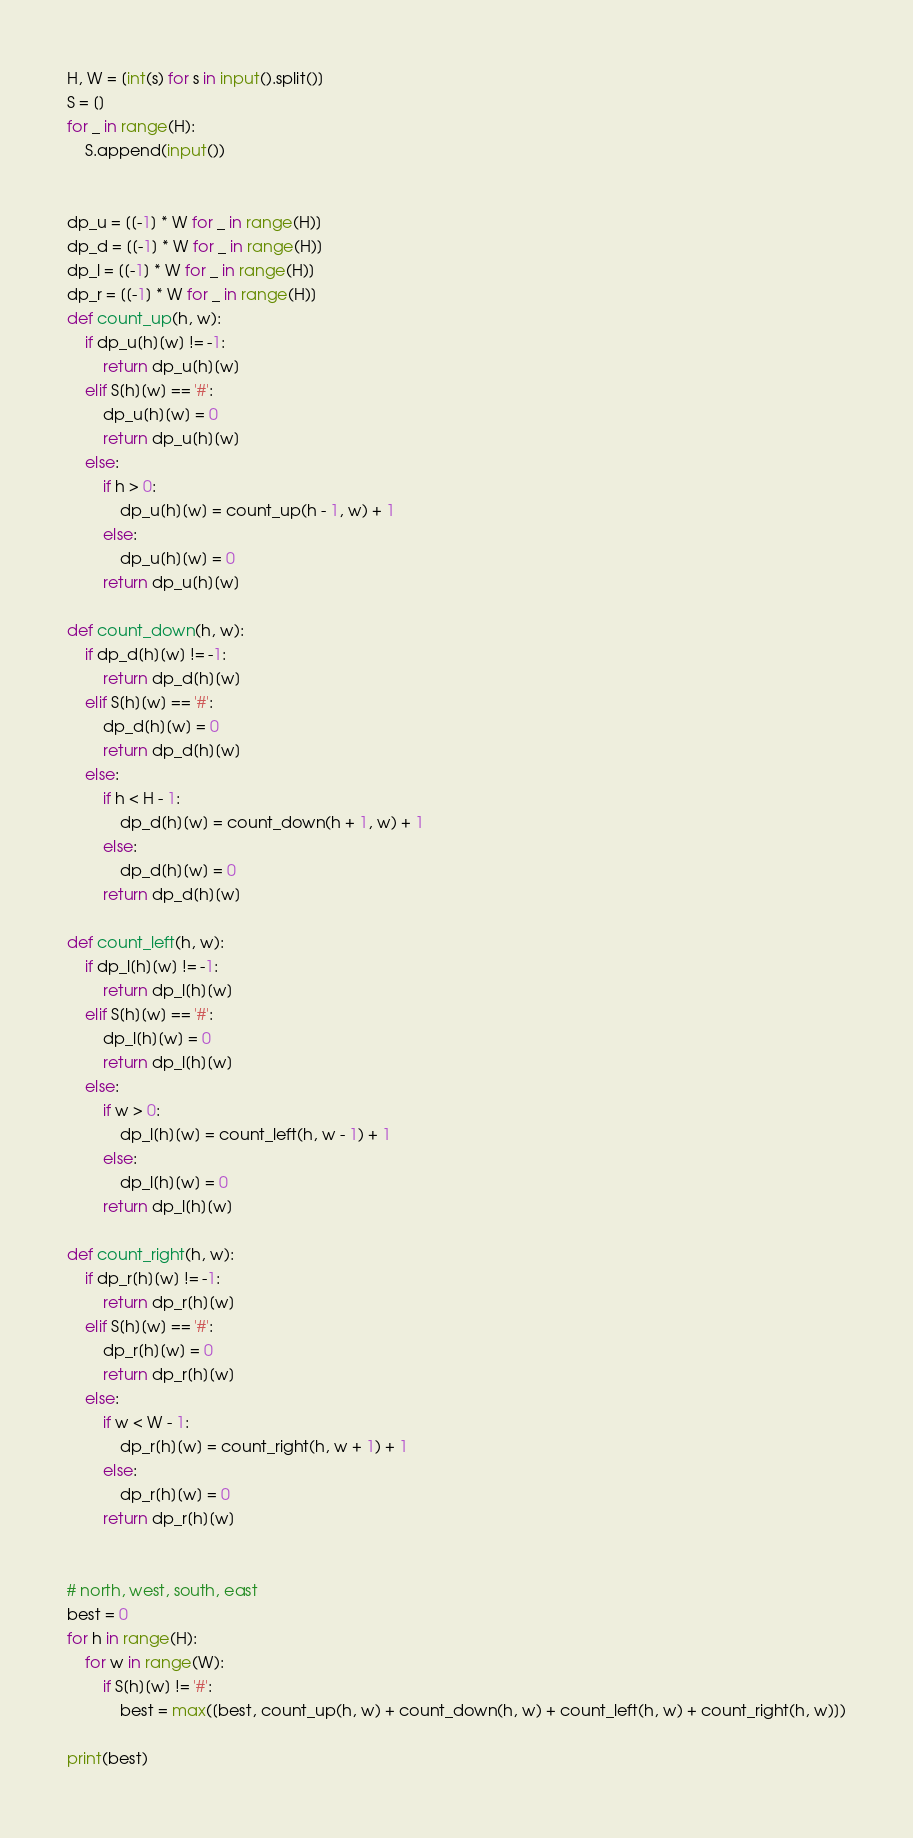<code> <loc_0><loc_0><loc_500><loc_500><_Python_>H, W = [int(s) for s in input().split()]
S = []
for _ in range(H):
    S.append(input())


dp_u = [[-1] * W for _ in range(H)]
dp_d = [[-1] * W for _ in range(H)]
dp_l = [[-1] * W for _ in range(H)]
dp_r = [[-1] * W for _ in range(H)]
def count_up(h, w):
    if dp_u[h][w] != -1:
        return dp_u[h][w]
    elif S[h][w] == '#':
        dp_u[h][w] = 0
        return dp_u[h][w]
    else:
        if h > 0:
            dp_u[h][w] = count_up(h - 1, w) + 1
        else:
            dp_u[h][w] = 0
        return dp_u[h][w]

def count_down(h, w):
    if dp_d[h][w] != -1:
        return dp_d[h][w]
    elif S[h][w] == '#':
        dp_d[h][w] = 0
        return dp_d[h][w]
    else:
        if h < H - 1:
            dp_d[h][w] = count_down(h + 1, w) + 1
        else:
            dp_d[h][w] = 0
        return dp_d[h][w]

def count_left(h, w):
    if dp_l[h][w] != -1:
        return dp_l[h][w]
    elif S[h][w] == '#':
        dp_l[h][w] = 0
        return dp_l[h][w]
    else:
        if w > 0:
            dp_l[h][w] = count_left(h, w - 1) + 1
        else:
            dp_l[h][w] = 0
        return dp_l[h][w]

def count_right(h, w):
    if dp_r[h][w] != -1:
        return dp_r[h][w]
    elif S[h][w] == '#':
        dp_r[h][w] = 0
        return dp_r[h][w]
    else:
        if w < W - 1:
            dp_r[h][w] = count_right(h, w + 1) + 1
        else:
            dp_r[h][w] = 0
        return dp_r[h][w]


# north, west, south, east
best = 0
for h in range(H):
    for w in range(W):
        if S[h][w] != '#':
            best = max([best, count_up(h, w) + count_down(h, w) + count_left(h, w) + count_right(h, w)])

print(best)
</code> 